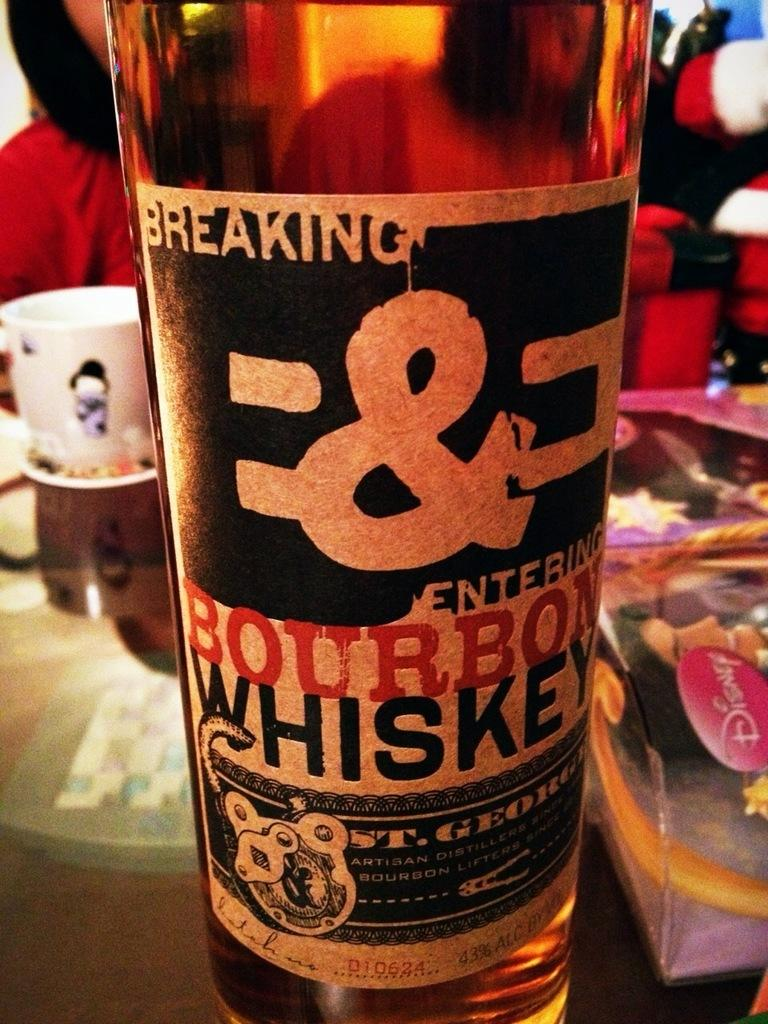<image>
Offer a succinct explanation of the picture presented. A bottle of B&E Bourbon Whiskey is on a table by a Disney toy. 